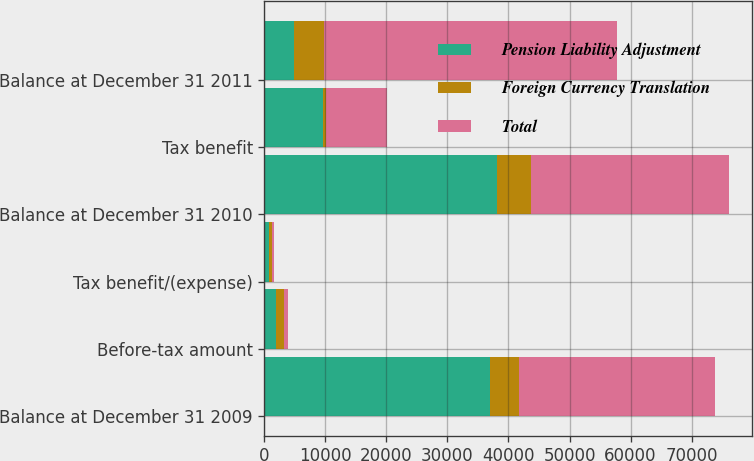<chart> <loc_0><loc_0><loc_500><loc_500><stacked_bar_chart><ecel><fcel>Balance at December 31 2009<fcel>Before-tax amount<fcel>Tax benefit/(expense)<fcel>Balance at December 31 2010<fcel>Tax benefit<fcel>Balance at December 31 2011<nl><fcel>Pension Liability Adjustment<fcel>36888<fcel>1933<fcel>744<fcel>38077<fcel>9605<fcel>4879<nl><fcel>Foreign Currency Translation<fcel>4761<fcel>1343<fcel>517<fcel>5587<fcel>417<fcel>4879<nl><fcel>Total<fcel>32127<fcel>590<fcel>227<fcel>32490<fcel>10022<fcel>48090<nl></chart> 